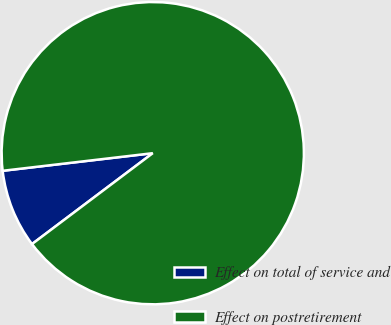Convert chart to OTSL. <chart><loc_0><loc_0><loc_500><loc_500><pie_chart><fcel>Effect on total of service and<fcel>Effect on postretirement<nl><fcel>8.41%<fcel>91.59%<nl></chart> 